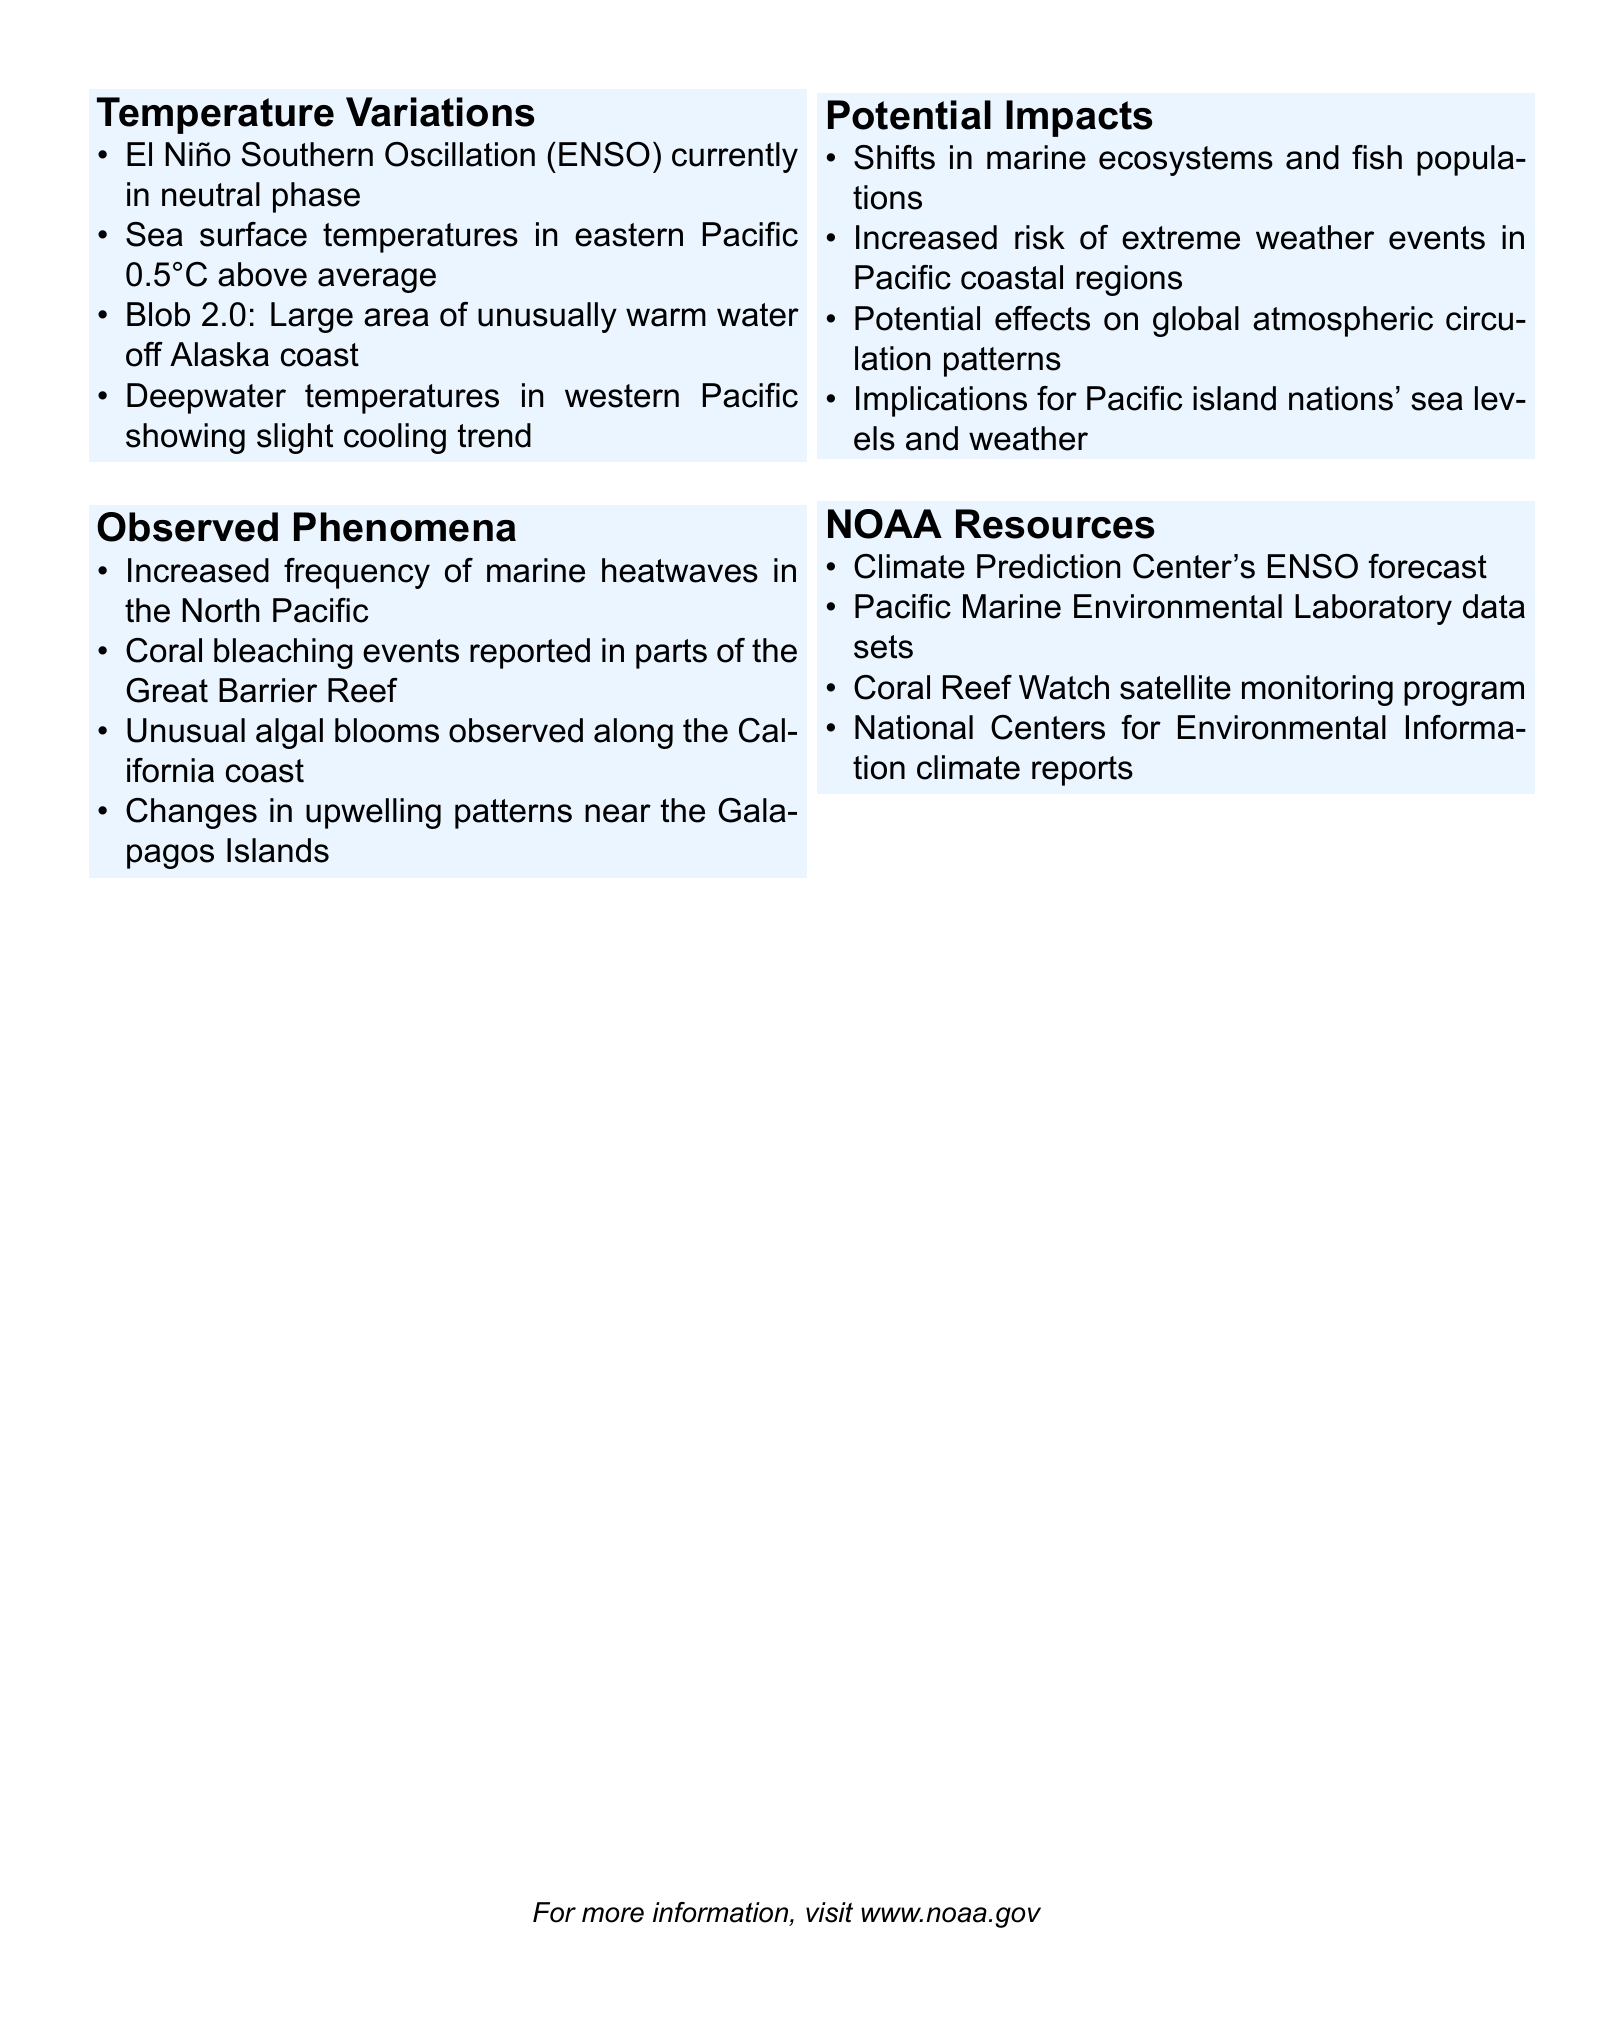What phase is the El Niño Southern Oscillation currently in? The document states that the El Niño Southern Oscillation (ENSO) is currently in a neutral phase.
Answer: Neutral phase What is the temperature difference of the sea surface in the eastern Pacific? The document notes that sea surface temperatures in the eastern Pacific are 0.5°C above average.
Answer: 0.5°C above average What unusual phenomenon is referred to as Blob 2.0? Blob 2.0 is described as a large area of unusually warm water off the Alaska coast.
Answer: Large area of unusually warm water off Alaska coast What event has been reported in parts of the Great Barrier Reef? The document mentions coral bleaching events have been reported in parts of the Great Barrier Reef.
Answer: Coral bleaching events What is one potential impact on Pacific island nations mentioned in the document? The potential impacts mentioned include implications for Pacific island nations' sea levels and weather.
Answer: Sea levels and weather What NOAA resource provides an ENSO forecast? The Climate Prediction Center's ENSO forecast is identified as a NOAA resource.
Answer: Climate Prediction Center's ENSO forecast Which observed phenomenon is related to changes in marine ecosystems? The document discusses shifts in marine ecosystems and fish populations as an observed phenomenon.
Answer: Shifts in marine ecosystems and fish populations What is a recent environmental change noted near the Galapagos Islands? Changes in upwelling patterns near the Galapagos Islands are noted as a recent environmental change.
Answer: Changes in upwelling patterns near the Galapagos Islands Which program monitors coral reefs from space? The Coral Reef Watch satellite monitoring program is mentioned as monitoring coral reefs.
Answer: Coral Reef Watch satellite monitoring program 